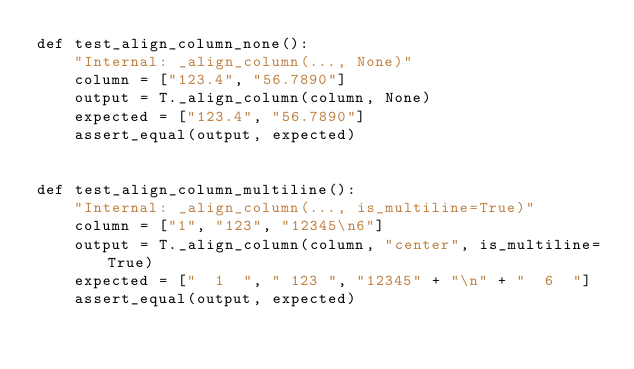Convert code to text. <code><loc_0><loc_0><loc_500><loc_500><_Python_>def test_align_column_none():
    "Internal: _align_column(..., None)"
    column = ["123.4", "56.7890"]
    output = T._align_column(column, None)
    expected = ["123.4", "56.7890"]
    assert_equal(output, expected)


def test_align_column_multiline():
    "Internal: _align_column(..., is_multiline=True)"
    column = ["1", "123", "12345\n6"]
    output = T._align_column(column, "center", is_multiline=True)
    expected = ["  1  ", " 123 ", "12345" + "\n" + "  6  "]
    assert_equal(output, expected)
</code> 